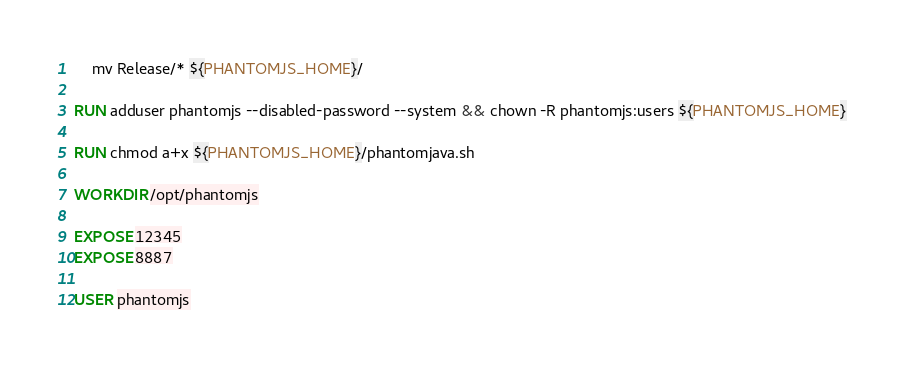<code> <loc_0><loc_0><loc_500><loc_500><_Dockerfile_>	mv Release/* ${PHANTOMJS_HOME}/

RUN adduser phantomjs --disabled-password --system && chown -R phantomjs:users ${PHANTOMJS_HOME}

RUN chmod a+x ${PHANTOMJS_HOME}/phantomjava.sh

WORKDIR /opt/phantomjs

EXPOSE 12345
EXPOSE 8887

USER phantomjs</code> 